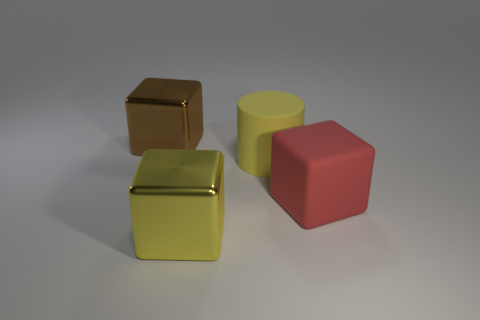How many tiny shiny objects are there?
Make the answer very short. 0. Is the yellow metal block the same size as the yellow cylinder?
Provide a short and direct response. Yes. What number of other objects are there of the same shape as the large red rubber thing?
Your answer should be compact. 2. What is the material of the big yellow thing that is behind the big rubber thing right of the big matte cylinder?
Your response must be concise. Rubber. There is a yellow cube; are there any large things to the right of it?
Keep it short and to the point. Yes. The red rubber object that is the same shape as the brown thing is what size?
Give a very brief answer. Large. What number of large things are either brown metal objects or yellow rubber cylinders?
Your answer should be very brief. 2. What number of metallic objects are behind the yellow matte cylinder and to the right of the brown object?
Your answer should be compact. 0. Is the material of the yellow block the same as the big block on the right side of the big yellow block?
Provide a succinct answer. No. What number of green things are large matte cylinders or tiny rubber spheres?
Provide a short and direct response. 0. 